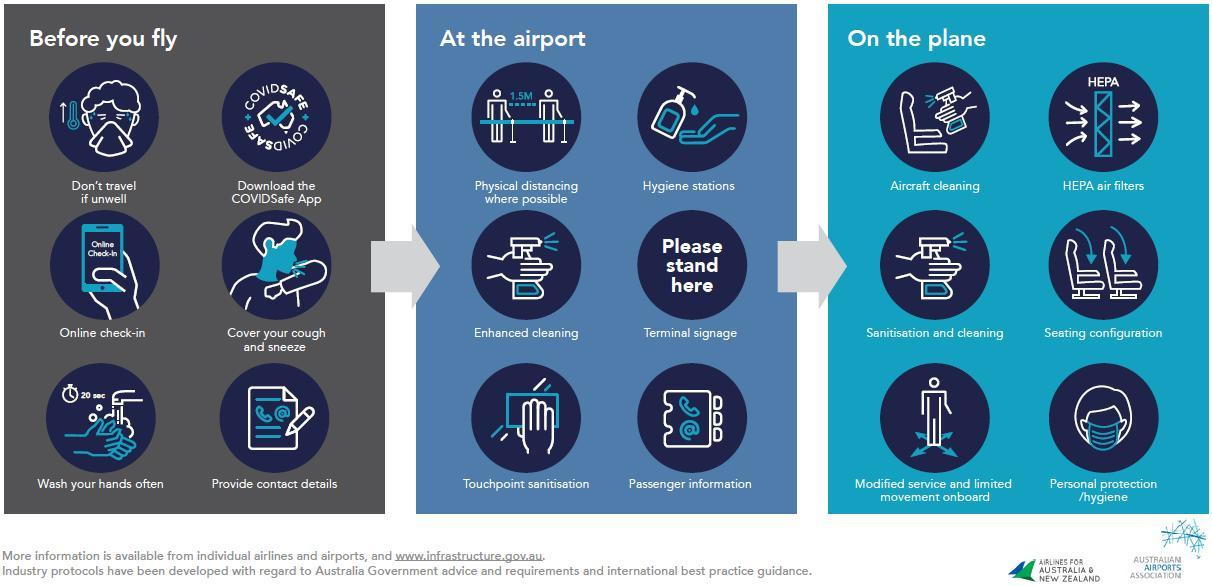Where are HEPA air filters found
Answer the question with a short phrase. On the plane when do we do online check-in before you fly the icon for enhanced cleaning is same as the icon for which other process sanitisation and cleaning where is touchpoint sanitisation important At the airport How many steps to follow before you fly 6 please stand here comes in which part of your journey At the airport 